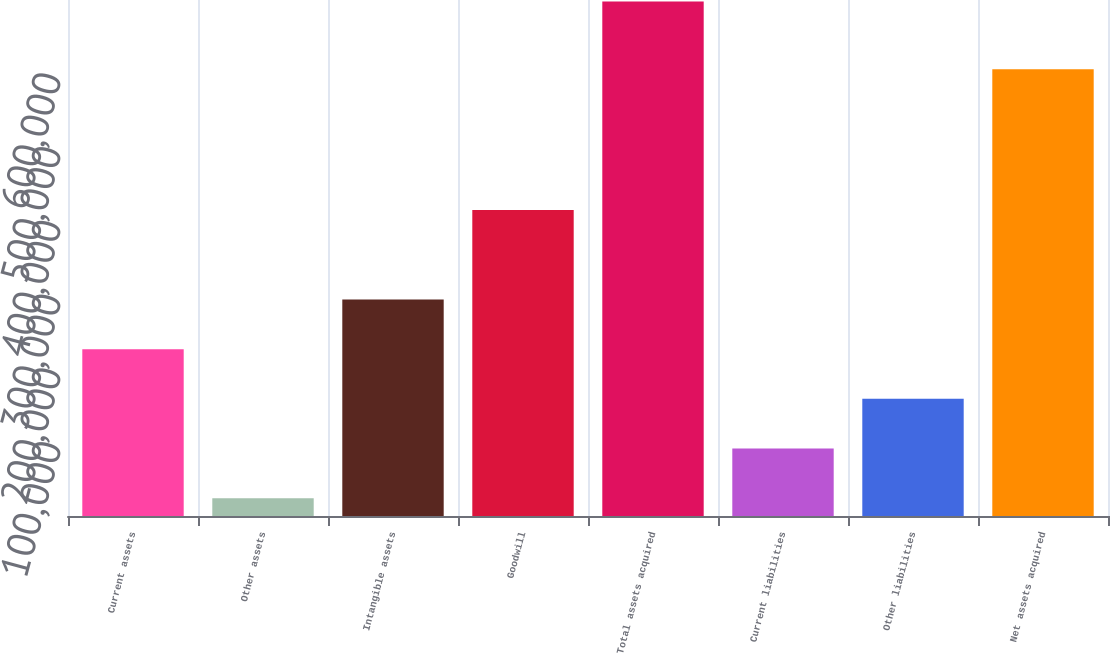Convert chart. <chart><loc_0><loc_0><loc_500><loc_500><bar_chart><fcel>Current assets<fcel>Other assets<fcel>Intangible assets<fcel>Goodwill<fcel>Total assets acquired<fcel>Current liabilities<fcel>Other liabilities<fcel>Net assets acquired<nl><fcel>226276<fcel>24161<fcel>293647<fcel>415136<fcel>697876<fcel>91532.5<fcel>158904<fcel>606028<nl></chart> 